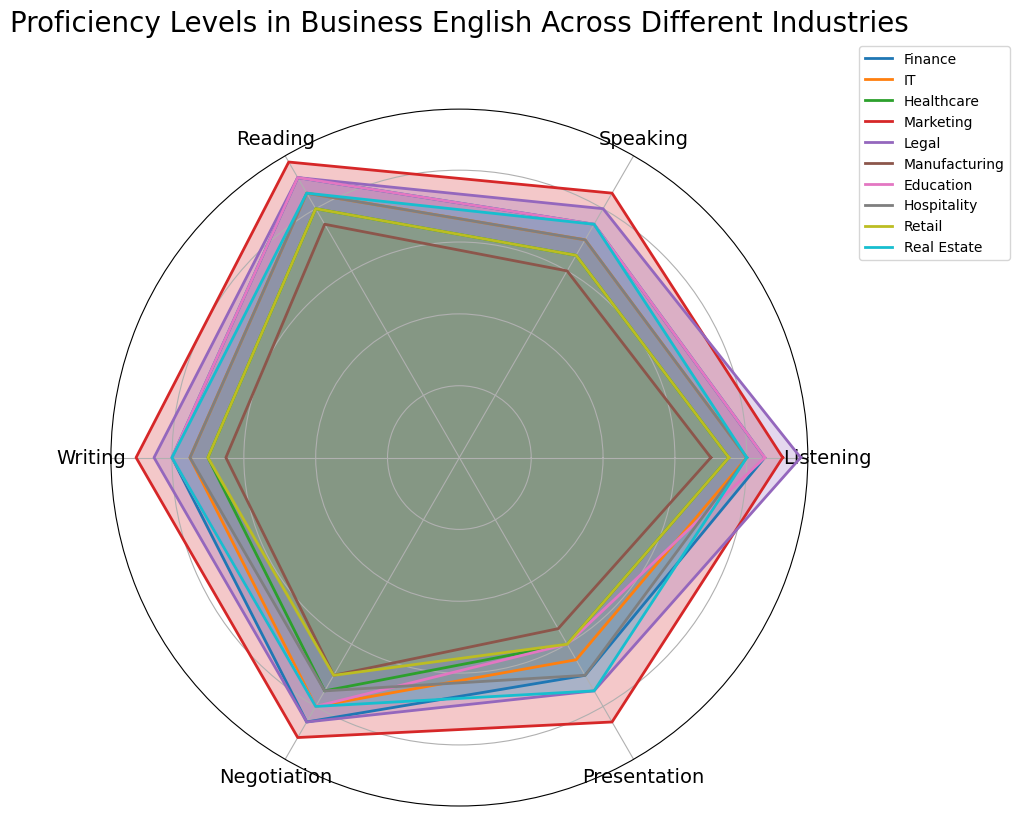Which industry shows the highest proficiency in Reading? To determine this, look at the radar chart and find the industry with the outermost point in the Reading category.
Answer: Marketing Which two industries have the closest proficiency levels in Speaking? Compare the proximity of the lines in the Speaking category for all industries.
Answer: Hospitality and IT What is the average proficiency level in Writing for Finance, Healthcare, and Education? Find the values for Writing in Finance (80), Healthcare (70), and Education (80). The average is (80 + 70 + 80) / 3 = 76.67.
Answer: 76.67 Which industry shows the lowest proficiency in Presentation? Look for the innermost point in the Presentation category on the radar chart.
Answer: Manufacturing How does the proficiency level in Negotiation of Legal compare to that of Retail? Compare the distance from the center to the points for Legal (85) and Retail (70) in the Negotiation category.
Answer: Legal is higher than Retail In which category does the Marketing industry outperform the majority of other industries? Identify the categories in which Marketing's data points are farther from the center compared to most other industries (e.g., Listening, Speaking, Reading, Writing, Negotiation).
Answer: Listening, Speaking, Reading, Writing, Negotiation Which industry has a more balanced proficiency in all categories, Marketing or Legal? Examine the radar chart for the polar plot showing a more uniform shape around the circle.
Answer: Marketing Between Hospitality and Real Estate, which industry shows higher proficiency in Listening? Compare the proximity to the edge at the Listening category for both Hospitality and Real Estate.
Answer: Real Estate 